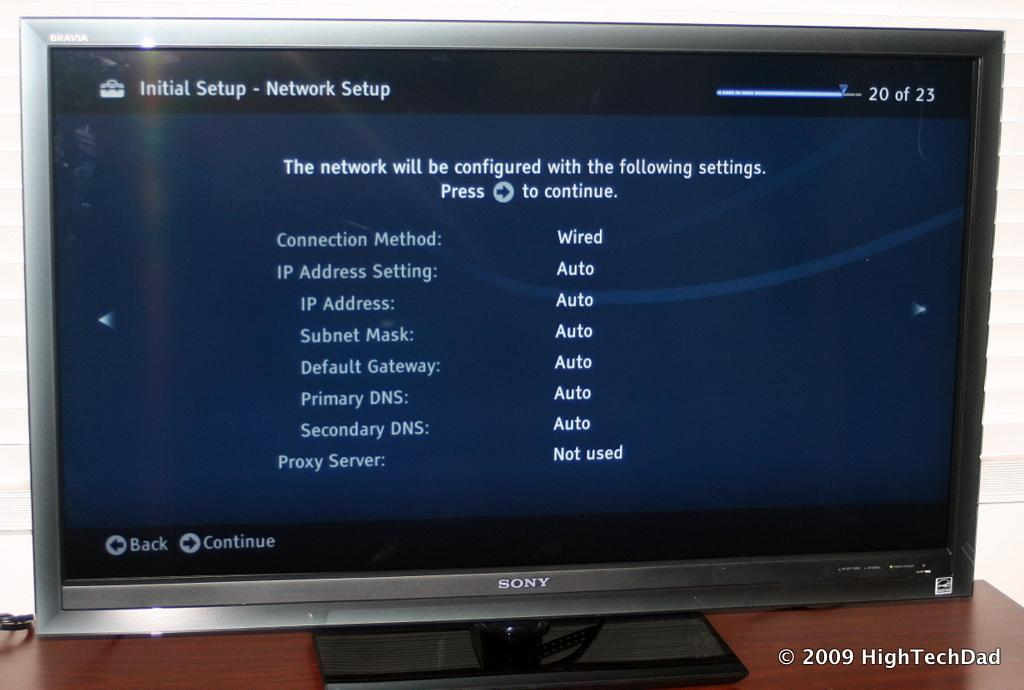<image>
Relay a brief, clear account of the picture shown. A computer monitor going through Initial Setup from the brand SONY. 